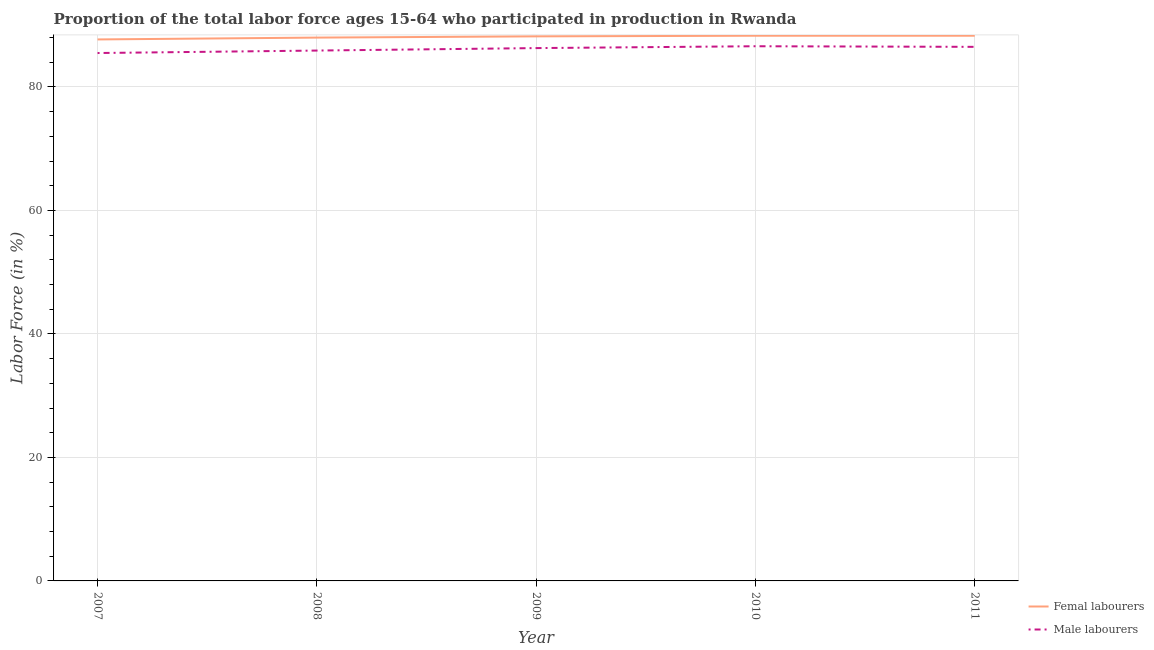How many different coloured lines are there?
Your answer should be very brief. 2. Does the line corresponding to percentage of male labour force intersect with the line corresponding to percentage of female labor force?
Give a very brief answer. No. What is the percentage of female labor force in 2011?
Provide a succinct answer. 88.3. Across all years, what is the maximum percentage of male labour force?
Provide a short and direct response. 86.6. Across all years, what is the minimum percentage of female labor force?
Ensure brevity in your answer.  87.7. In which year was the percentage of female labor force maximum?
Give a very brief answer. 2010. What is the total percentage of female labor force in the graph?
Provide a succinct answer. 440.5. What is the difference between the percentage of female labor force in 2008 and that in 2011?
Ensure brevity in your answer.  -0.3. What is the difference between the percentage of male labour force in 2009 and the percentage of female labor force in 2008?
Give a very brief answer. -1.7. What is the average percentage of female labor force per year?
Offer a terse response. 88.1. In the year 2009, what is the difference between the percentage of female labor force and percentage of male labour force?
Keep it short and to the point. 1.9. What is the ratio of the percentage of female labor force in 2007 to that in 2010?
Make the answer very short. 0.99. Is the difference between the percentage of male labour force in 2007 and 2011 greater than the difference between the percentage of female labor force in 2007 and 2011?
Your answer should be very brief. No. What is the difference between the highest and the second highest percentage of female labor force?
Offer a terse response. 0. What is the difference between the highest and the lowest percentage of female labor force?
Offer a very short reply. 0.6. Does the percentage of male labour force monotonically increase over the years?
Give a very brief answer. No. Is the percentage of male labour force strictly greater than the percentage of female labor force over the years?
Provide a short and direct response. No. How many lines are there?
Offer a terse response. 2. How many years are there in the graph?
Offer a very short reply. 5. Are the values on the major ticks of Y-axis written in scientific E-notation?
Offer a terse response. No. Does the graph contain grids?
Your answer should be very brief. Yes. Where does the legend appear in the graph?
Your answer should be compact. Bottom right. How are the legend labels stacked?
Ensure brevity in your answer.  Vertical. What is the title of the graph?
Make the answer very short. Proportion of the total labor force ages 15-64 who participated in production in Rwanda. Does "Fixed telephone" appear as one of the legend labels in the graph?
Offer a very short reply. No. What is the Labor Force (in %) in Femal labourers in 2007?
Keep it short and to the point. 87.7. What is the Labor Force (in %) of Male labourers in 2007?
Make the answer very short. 85.5. What is the Labor Force (in %) in Male labourers in 2008?
Provide a short and direct response. 85.9. What is the Labor Force (in %) of Femal labourers in 2009?
Make the answer very short. 88.2. What is the Labor Force (in %) of Male labourers in 2009?
Provide a succinct answer. 86.3. What is the Labor Force (in %) of Femal labourers in 2010?
Offer a very short reply. 88.3. What is the Labor Force (in %) in Male labourers in 2010?
Provide a short and direct response. 86.6. What is the Labor Force (in %) in Femal labourers in 2011?
Give a very brief answer. 88.3. What is the Labor Force (in %) in Male labourers in 2011?
Provide a short and direct response. 86.5. Across all years, what is the maximum Labor Force (in %) in Femal labourers?
Offer a very short reply. 88.3. Across all years, what is the maximum Labor Force (in %) in Male labourers?
Provide a short and direct response. 86.6. Across all years, what is the minimum Labor Force (in %) of Femal labourers?
Offer a very short reply. 87.7. Across all years, what is the minimum Labor Force (in %) of Male labourers?
Provide a succinct answer. 85.5. What is the total Labor Force (in %) of Femal labourers in the graph?
Offer a very short reply. 440.5. What is the total Labor Force (in %) of Male labourers in the graph?
Provide a short and direct response. 430.8. What is the difference between the Labor Force (in %) in Femal labourers in 2007 and that in 2008?
Give a very brief answer. -0.3. What is the difference between the Labor Force (in %) of Male labourers in 2007 and that in 2008?
Offer a very short reply. -0.4. What is the difference between the Labor Force (in %) of Femal labourers in 2007 and that in 2009?
Keep it short and to the point. -0.5. What is the difference between the Labor Force (in %) in Male labourers in 2007 and that in 2010?
Keep it short and to the point. -1.1. What is the difference between the Labor Force (in %) in Femal labourers in 2008 and that in 2009?
Offer a very short reply. -0.2. What is the difference between the Labor Force (in %) in Male labourers in 2008 and that in 2011?
Give a very brief answer. -0.6. What is the difference between the Labor Force (in %) of Femal labourers in 2009 and that in 2011?
Ensure brevity in your answer.  -0.1. What is the difference between the Labor Force (in %) in Femal labourers in 2010 and that in 2011?
Your answer should be very brief. 0. What is the difference between the Labor Force (in %) of Male labourers in 2010 and that in 2011?
Offer a very short reply. 0.1. What is the difference between the Labor Force (in %) in Femal labourers in 2007 and the Labor Force (in %) in Male labourers in 2008?
Make the answer very short. 1.8. What is the difference between the Labor Force (in %) in Femal labourers in 2007 and the Labor Force (in %) in Male labourers in 2010?
Provide a succinct answer. 1.1. What is the difference between the Labor Force (in %) in Femal labourers in 2007 and the Labor Force (in %) in Male labourers in 2011?
Offer a terse response. 1.2. What is the difference between the Labor Force (in %) in Femal labourers in 2008 and the Labor Force (in %) in Male labourers in 2009?
Offer a very short reply. 1.7. What is the difference between the Labor Force (in %) of Femal labourers in 2008 and the Labor Force (in %) of Male labourers in 2011?
Keep it short and to the point. 1.5. What is the average Labor Force (in %) of Femal labourers per year?
Provide a succinct answer. 88.1. What is the average Labor Force (in %) of Male labourers per year?
Give a very brief answer. 86.16. In the year 2010, what is the difference between the Labor Force (in %) in Femal labourers and Labor Force (in %) in Male labourers?
Give a very brief answer. 1.7. What is the ratio of the Labor Force (in %) in Femal labourers in 2007 to that in 2008?
Your answer should be very brief. 1. What is the ratio of the Labor Force (in %) in Femal labourers in 2007 to that in 2010?
Offer a terse response. 0.99. What is the ratio of the Labor Force (in %) in Male labourers in 2007 to that in 2010?
Keep it short and to the point. 0.99. What is the ratio of the Labor Force (in %) of Male labourers in 2007 to that in 2011?
Ensure brevity in your answer.  0.99. What is the ratio of the Labor Force (in %) in Femal labourers in 2008 to that in 2009?
Offer a terse response. 1. What is the ratio of the Labor Force (in %) in Male labourers in 2008 to that in 2009?
Provide a succinct answer. 1. What is the ratio of the Labor Force (in %) in Male labourers in 2008 to that in 2010?
Ensure brevity in your answer.  0.99. What is the ratio of the Labor Force (in %) in Femal labourers in 2008 to that in 2011?
Your answer should be very brief. 1. What is the ratio of the Labor Force (in %) of Male labourers in 2009 to that in 2010?
Keep it short and to the point. 1. What is the ratio of the Labor Force (in %) of Femal labourers in 2009 to that in 2011?
Make the answer very short. 1. What is the ratio of the Labor Force (in %) in Male labourers in 2010 to that in 2011?
Provide a short and direct response. 1. What is the difference between the highest and the second highest Labor Force (in %) of Femal labourers?
Your response must be concise. 0. What is the difference between the highest and the second highest Labor Force (in %) in Male labourers?
Your response must be concise. 0.1. What is the difference between the highest and the lowest Labor Force (in %) of Femal labourers?
Your answer should be very brief. 0.6. 